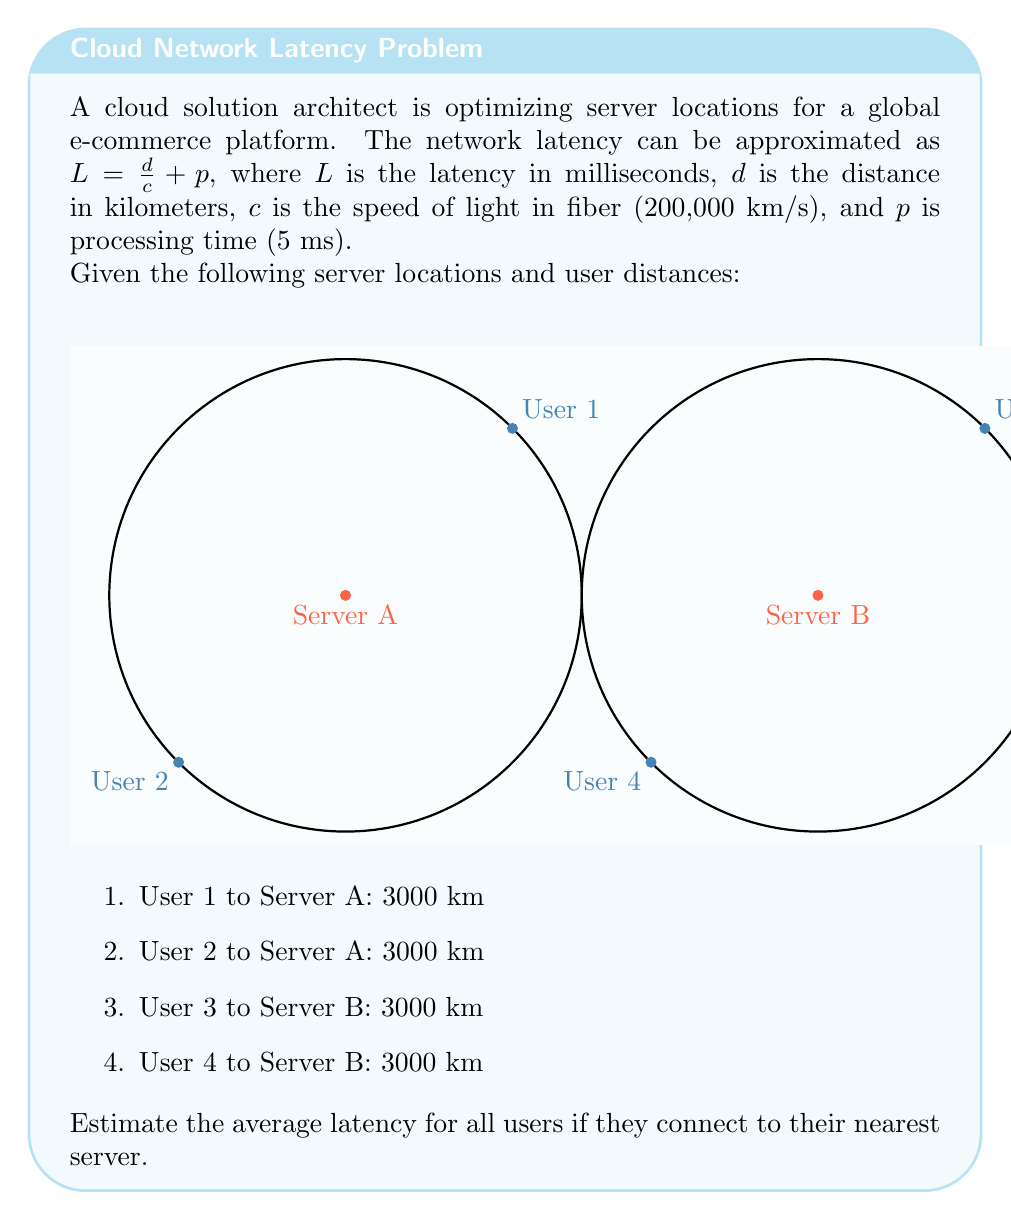Give your solution to this math problem. Let's solve this step-by-step:

1) First, we need to calculate the latency for each user:

   $L = \frac{d}{c} + p$
   
   Where:
   $d = 3000$ km (for all users)
   $c = 200,000$ km/s
   $p = 5$ ms

2) Substituting these values:

   $L = \frac{3000}{200,000} + 5$

3) Simplifying:

   $L = 0.015 + 5 = 5.015$ ms

4) This latency is the same for all users since they are all 3000 km from their nearest server.

5) To find the average latency, we sum up all latencies and divide by the number of users:

   $\text{Average Latency} = \frac{5.015 + 5.015 + 5.015 + 5.015}{4} = 5.015$ ms

Therefore, the average latency for all users is 5.015 ms.
Answer: 5.015 ms 